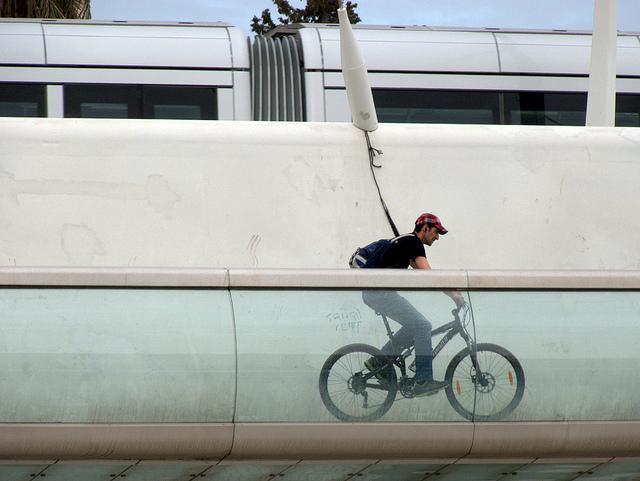How many buses are there?
Give a very brief answer. 0. 